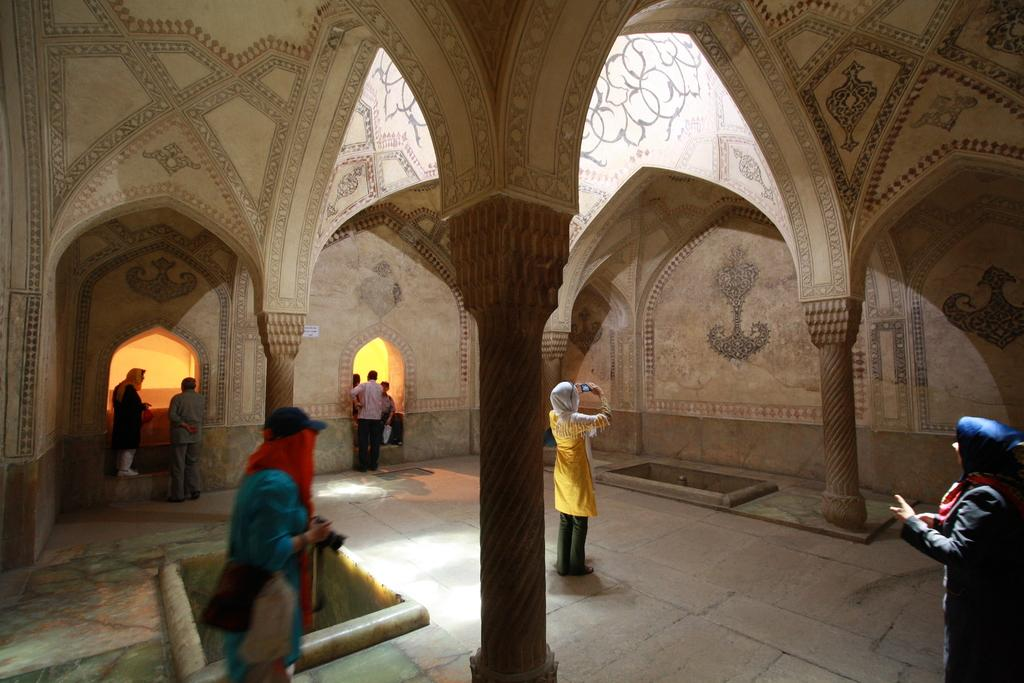Who or what can be seen in the image? There are people in the image. What architectural features are present in the image? There are four pillars in the image. What can be observed on the walls in the image? There are designs on the walls in the image. What type of oven can be seen in the image? There is no oven present in the image. How many pipes are visible in the image? There is no mention of pipes in the provided facts, so we cannot determine the number of pipes in the image. 